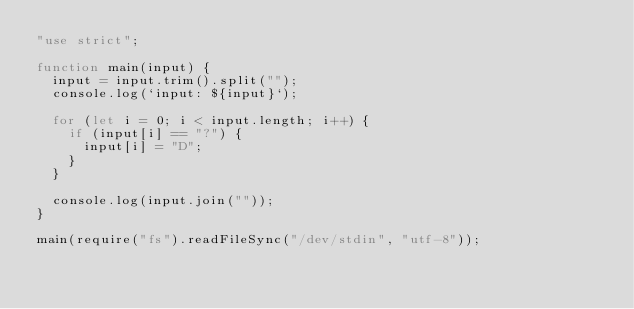<code> <loc_0><loc_0><loc_500><loc_500><_JavaScript_>"use strict";

function main(input) {
  input = input.trim().split("");
  console.log(`input: ${input}`);

  for (let i = 0; i < input.length; i++) {
    if (input[i] == "?") {
      input[i] = "D";
    }
  }

  console.log(input.join(""));
}

main(require("fs").readFileSync("/dev/stdin", "utf-8"));
</code> 